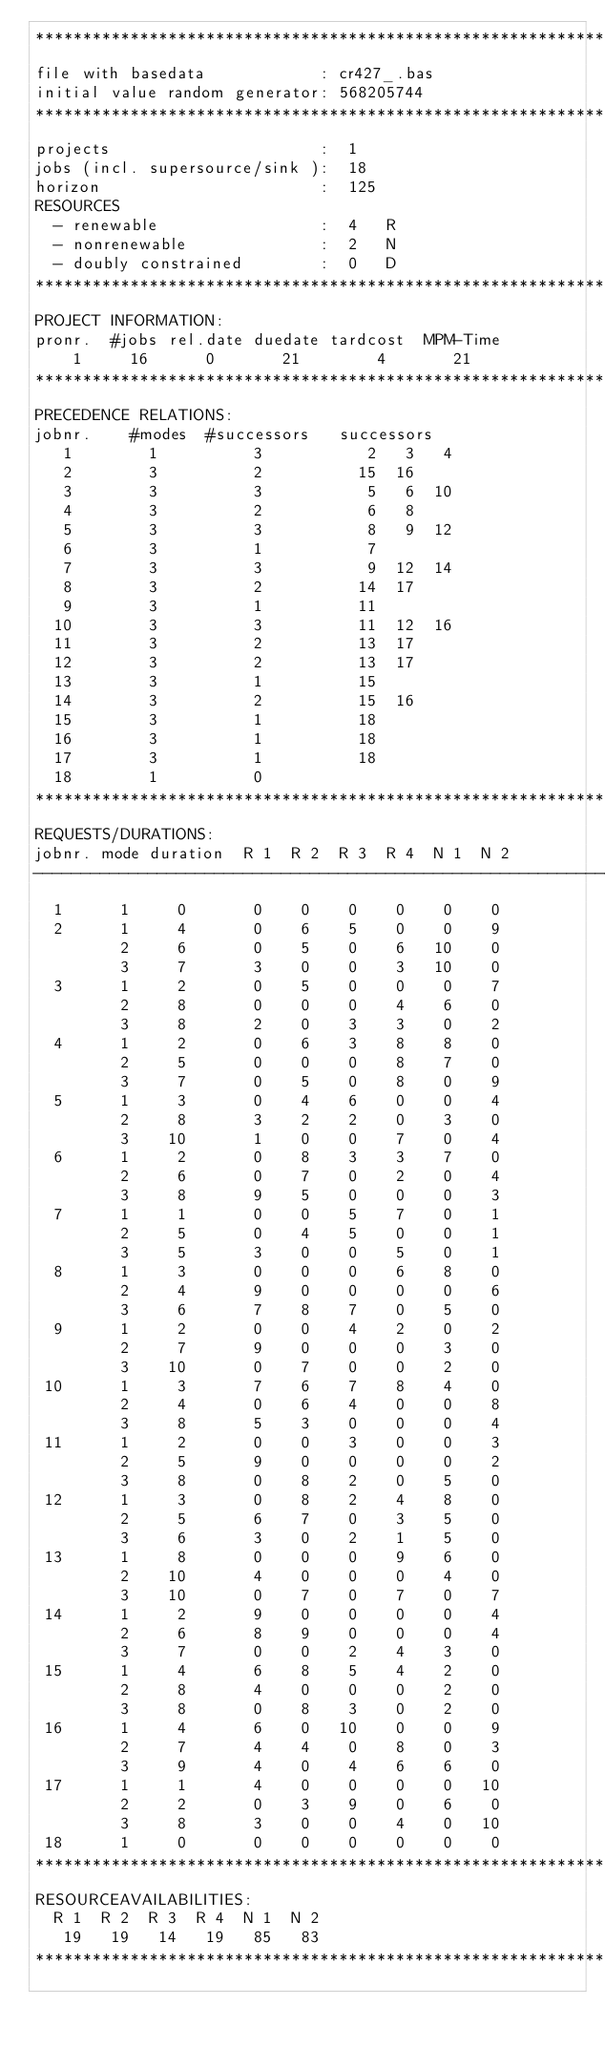<code> <loc_0><loc_0><loc_500><loc_500><_ObjectiveC_>************************************************************************
file with basedata            : cr427_.bas
initial value random generator: 568205744
************************************************************************
projects                      :  1
jobs (incl. supersource/sink ):  18
horizon                       :  125
RESOURCES
  - renewable                 :  4   R
  - nonrenewable              :  2   N
  - doubly constrained        :  0   D
************************************************************************
PROJECT INFORMATION:
pronr.  #jobs rel.date duedate tardcost  MPM-Time
    1     16      0       21        4       21
************************************************************************
PRECEDENCE RELATIONS:
jobnr.    #modes  #successors   successors
   1        1          3           2   3   4
   2        3          2          15  16
   3        3          3           5   6  10
   4        3          2           6   8
   5        3          3           8   9  12
   6        3          1           7
   7        3          3           9  12  14
   8        3          2          14  17
   9        3          1          11
  10        3          3          11  12  16
  11        3          2          13  17
  12        3          2          13  17
  13        3          1          15
  14        3          2          15  16
  15        3          1          18
  16        3          1          18
  17        3          1          18
  18        1          0        
************************************************************************
REQUESTS/DURATIONS:
jobnr. mode duration  R 1  R 2  R 3  R 4  N 1  N 2
------------------------------------------------------------------------
  1      1     0       0    0    0    0    0    0
  2      1     4       0    6    5    0    0    9
         2     6       0    5    0    6   10    0
         3     7       3    0    0    3   10    0
  3      1     2       0    5    0    0    0    7
         2     8       0    0    0    4    6    0
         3     8       2    0    3    3    0    2
  4      1     2       0    6    3    8    8    0
         2     5       0    0    0    8    7    0
         3     7       0    5    0    8    0    9
  5      1     3       0    4    6    0    0    4
         2     8       3    2    2    0    3    0
         3    10       1    0    0    7    0    4
  6      1     2       0    8    3    3    7    0
         2     6       0    7    0    2    0    4
         3     8       9    5    0    0    0    3
  7      1     1       0    0    5    7    0    1
         2     5       0    4    5    0    0    1
         3     5       3    0    0    5    0    1
  8      1     3       0    0    0    6    8    0
         2     4       9    0    0    0    0    6
         3     6       7    8    7    0    5    0
  9      1     2       0    0    4    2    0    2
         2     7       9    0    0    0    3    0
         3    10       0    7    0    0    2    0
 10      1     3       7    6    7    8    4    0
         2     4       0    6    4    0    0    8
         3     8       5    3    0    0    0    4
 11      1     2       0    0    3    0    0    3
         2     5       9    0    0    0    0    2
         3     8       0    8    2    0    5    0
 12      1     3       0    8    2    4    8    0
         2     5       6    7    0    3    5    0
         3     6       3    0    2    1    5    0
 13      1     8       0    0    0    9    6    0
         2    10       4    0    0    0    4    0
         3    10       0    7    0    7    0    7
 14      1     2       9    0    0    0    0    4
         2     6       8    9    0    0    0    4
         3     7       0    0    2    4    3    0
 15      1     4       6    8    5    4    2    0
         2     8       4    0    0    0    2    0
         3     8       0    8    3    0    2    0
 16      1     4       6    0   10    0    0    9
         2     7       4    4    0    8    0    3
         3     9       4    0    4    6    6    0
 17      1     1       4    0    0    0    0   10
         2     2       0    3    9    0    6    0
         3     8       3    0    0    4    0   10
 18      1     0       0    0    0    0    0    0
************************************************************************
RESOURCEAVAILABILITIES:
  R 1  R 2  R 3  R 4  N 1  N 2
   19   19   14   19   85   83
************************************************************************
</code> 